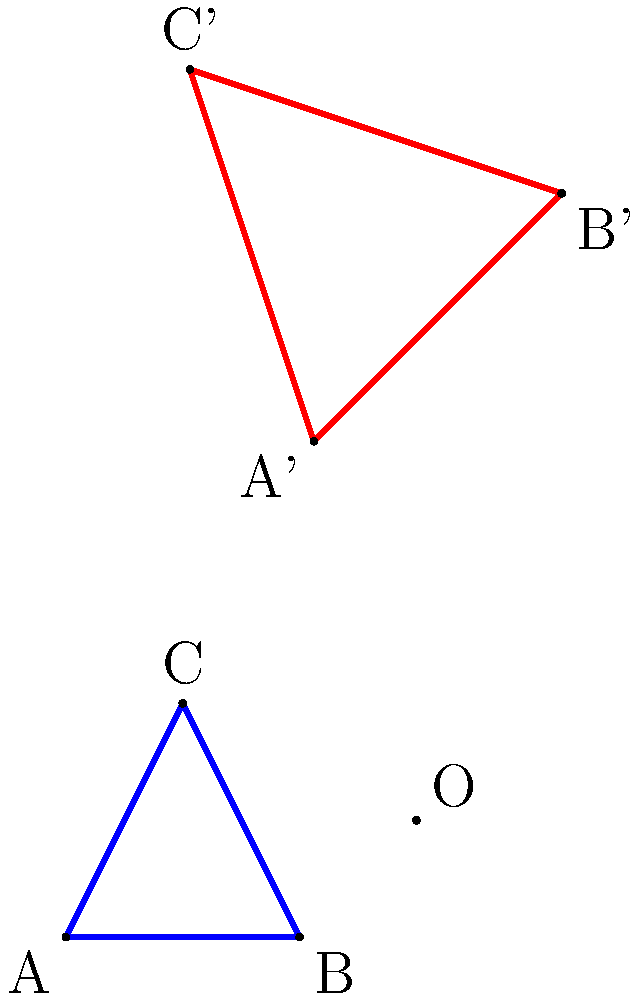Given triangle ABC with vertices A(0,0), B(2,0), and C(1,2), apply the following transformations in order:
1. Translation by vector (3,1)
2. Scaling by a factor of 1.5 with respect to the origin
3. Rotation by 45° counterclockwise around the origin

What are the coordinates of the transformed vertices A', B', and C' after applying all these transformations? Let's approach this step-by-step:

1. First, we need to combine the transformations in the correct order. The order of transformations is important, and we apply them from right to left. So, our combined transformation T is:
   T = Rotation * Scaling * Translation

2. Translation by (3,1):
   This moves all points by adding (3,1) to their coordinates.

3. Scaling by 1.5:
   This multiplies all coordinates by 1.5.

4. Rotation by 45°:
   We use the rotation matrix: 
   $$\begin{pmatrix} \cos 45° & -\sin 45° \\ \sin 45° & \cos 45° \end{pmatrix} = \begin{pmatrix} \frac{\sqrt{2}}{2} & -\frac{\sqrt{2}}{2} \\ \frac{\sqrt{2}}{2} & \frac{\sqrt{2}}{2} \end{pmatrix}$$

5. Now, let's apply these transformations to each point:

   For A(0,0):
   - After translation: (3,1)
   - After scaling: (4.5,1.5)
   - After rotation: (4.5 * √2/2 - 1.5 * √2/2, 4.5 * √2/2 + 1.5 * √2/2) ≈ (2.12, 4.24)

   For B(2,0):
   - After translation: (5,1)
   - After scaling: (7.5,1.5)
   - After rotation: (7.5 * √2/2 - 1.5 * √2/2, 7.5 * √2/2 + 1.5 * √2/2) ≈ (4.24, 6.36)

   For C(1,2):
   - After translation: (4,3)
   - After scaling: (6,4.5)
   - After rotation: (6 * √2/2 - 4.5 * √2/2, 6 * √2/2 + 4.5 * √2/2) ≈ (1.06, 7.42)

6. Rounding to two decimal places, we get:
   A' ≈ (2.12, 4.24)
   B' ≈ (4.24, 6.36)
   C' ≈ (1.06, 7.42)
Answer: A'(2.12, 4.24), B'(4.24, 6.36), C'(1.06, 7.42) 